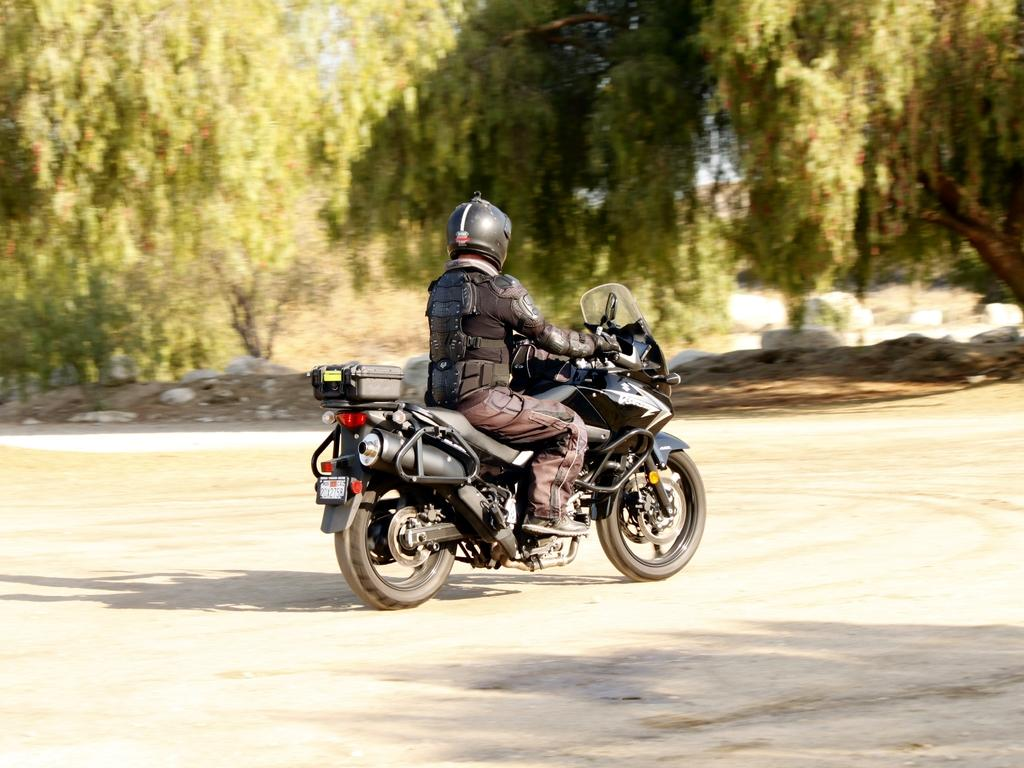Who is the person in the image? There is a man in the image. What is the man doing in the image? The man is on a bike. What can be seen in the background of the image? There are trees at the top side of the image. What type of arch does the man need to cross in the image? There is no arch present in the image. 